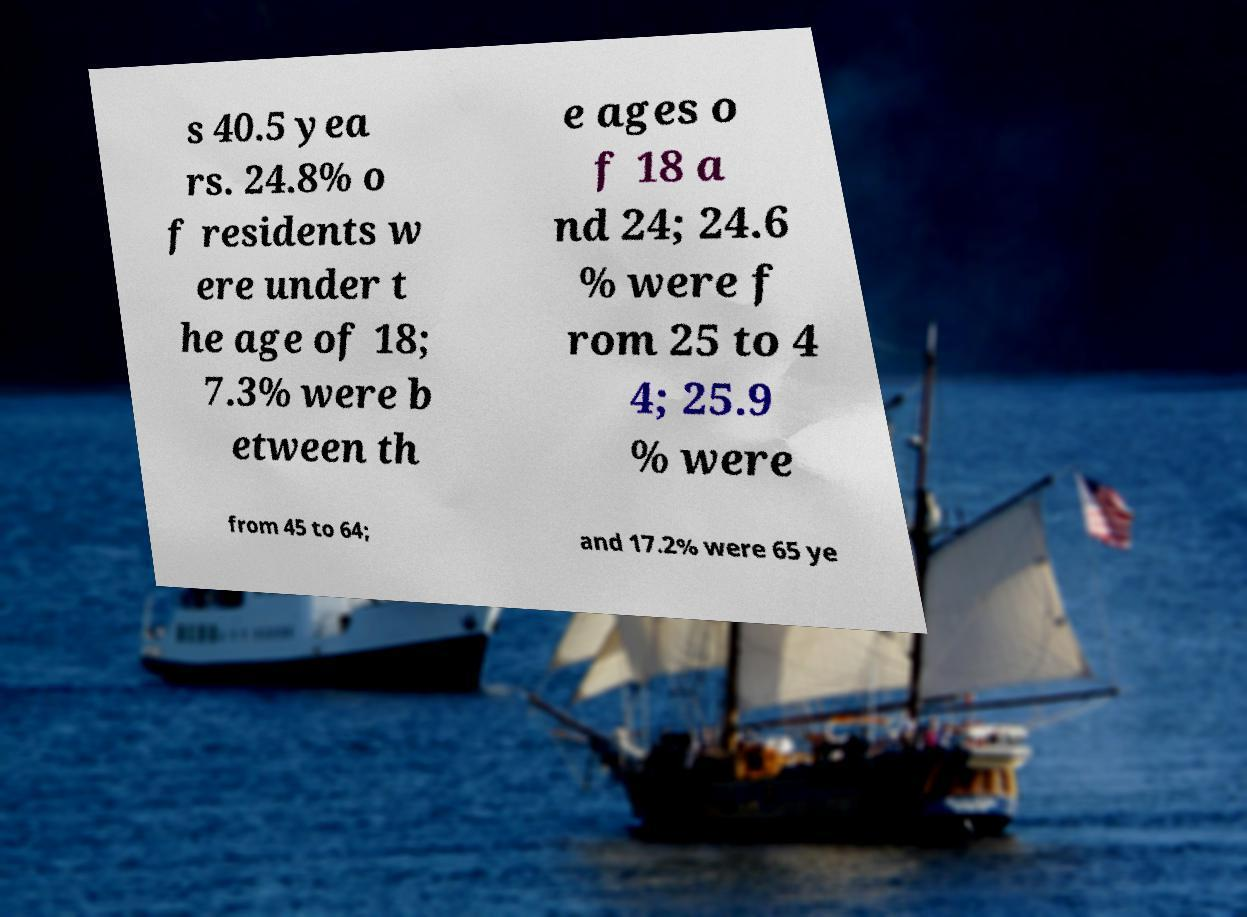I need the written content from this picture converted into text. Can you do that? s 40.5 yea rs. 24.8% o f residents w ere under t he age of 18; 7.3% were b etween th e ages o f 18 a nd 24; 24.6 % were f rom 25 to 4 4; 25.9 % were from 45 to 64; and 17.2% were 65 ye 